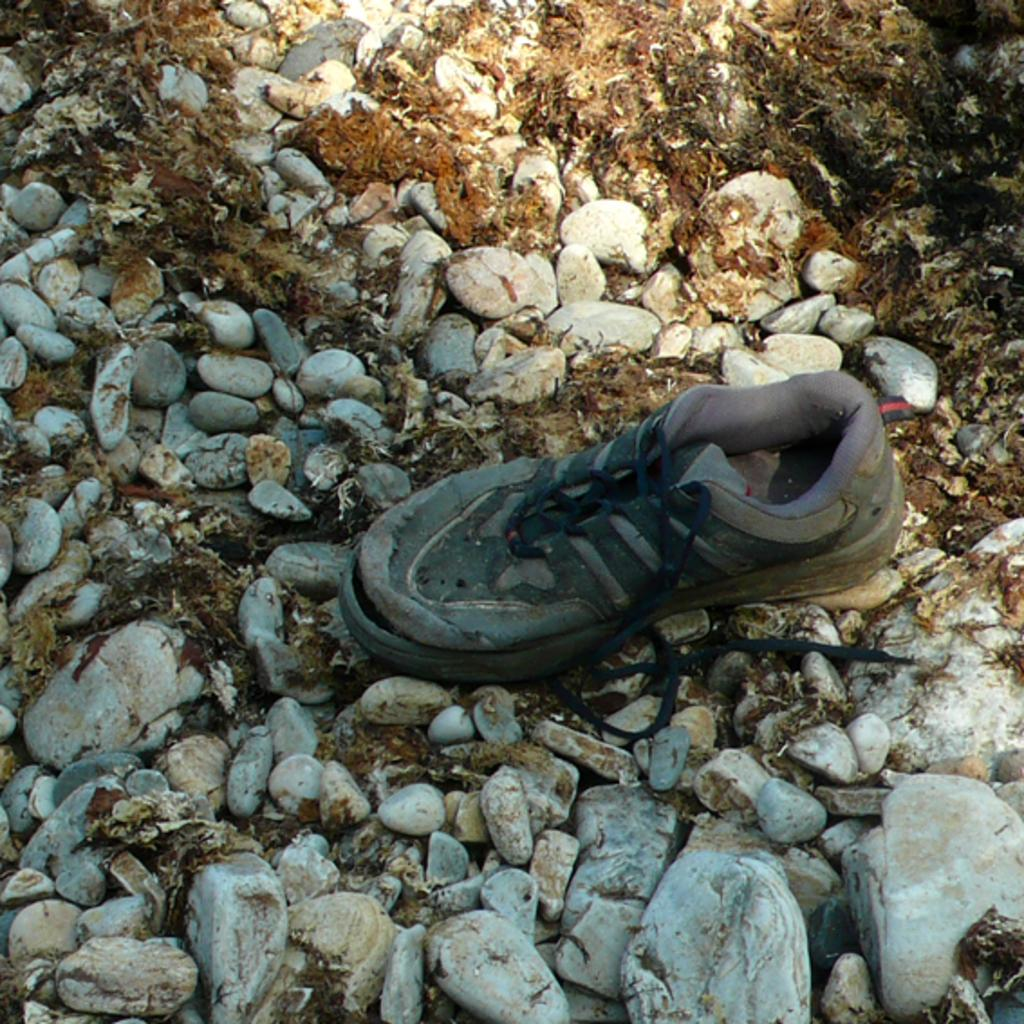What object is present in the image? There is a shoe in the image. What can be seen on the ground in the image? There are stones on the ground in the image. How does the flock of birds fly over the shoe in the image? There are no birds present in the image, so it is not possible to answer that question. 